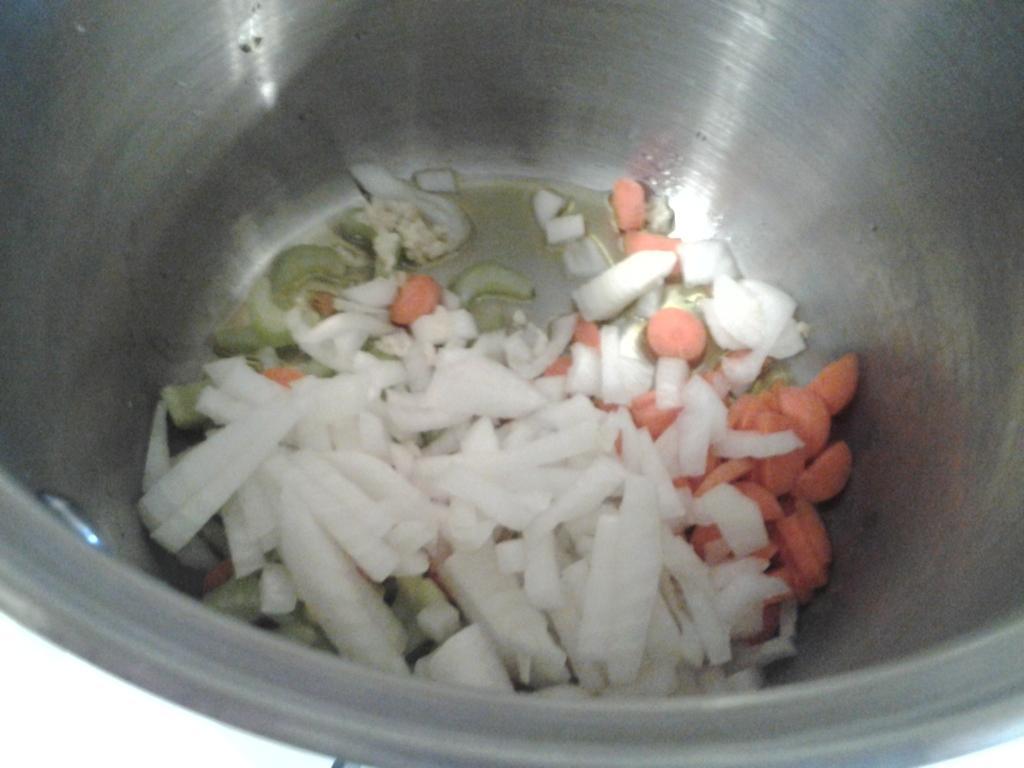Describe this image in one or two sentences. In this picture we can see some vegetables are in a vessel. 